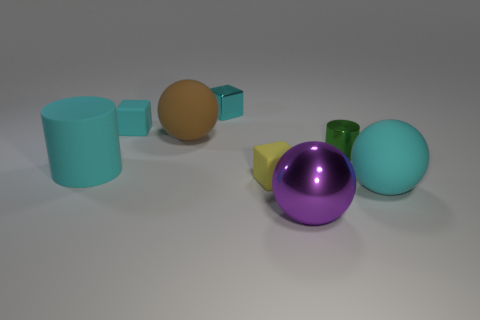Subtract all green cubes. Subtract all purple balls. How many cubes are left? 3 Add 1 brown matte objects. How many objects exist? 9 Subtract all balls. How many objects are left? 5 Add 7 brown objects. How many brown objects exist? 8 Subtract 0 purple blocks. How many objects are left? 8 Subtract all large cyan metallic cylinders. Subtract all big brown spheres. How many objects are left? 7 Add 5 brown rubber spheres. How many brown rubber spheres are left? 6 